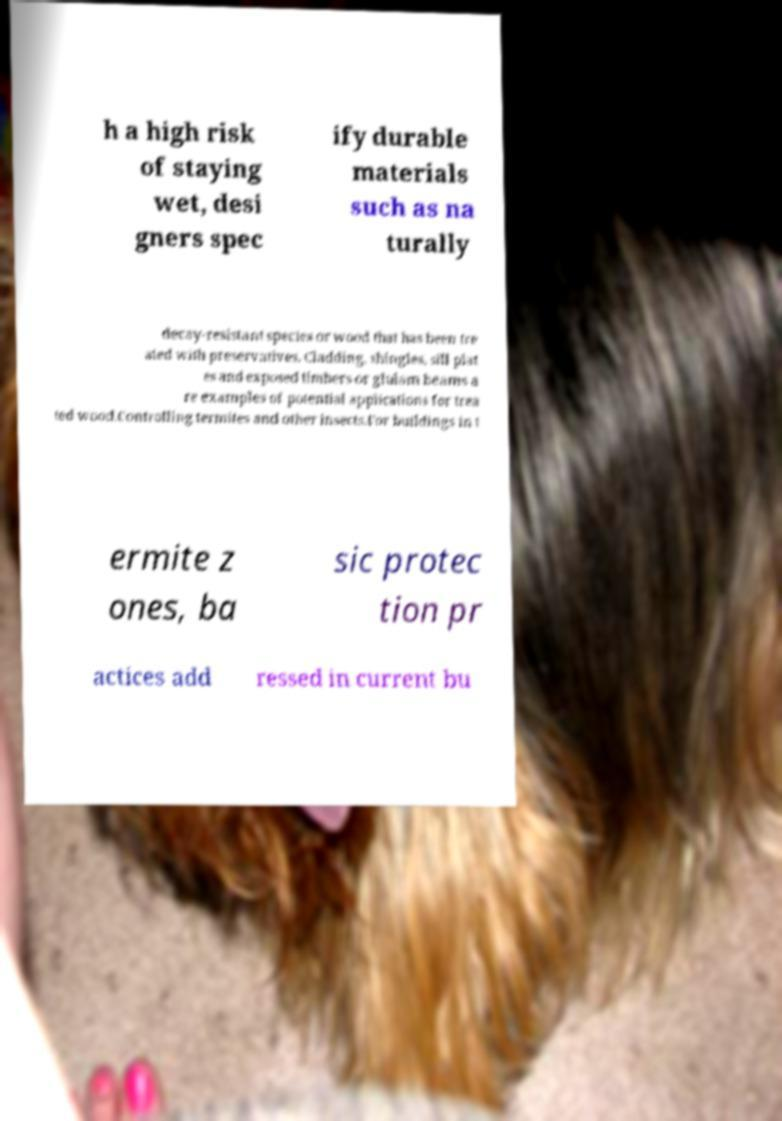Please identify and transcribe the text found in this image. h a high risk of staying wet, desi gners spec ify durable materials such as na turally decay-resistant species or wood that has been tre ated with preservatives. Cladding, shingles, sill plat es and exposed timbers or glulam beams a re examples of potential applications for trea ted wood.Controlling termites and other insects.For buildings in t ermite z ones, ba sic protec tion pr actices add ressed in current bu 